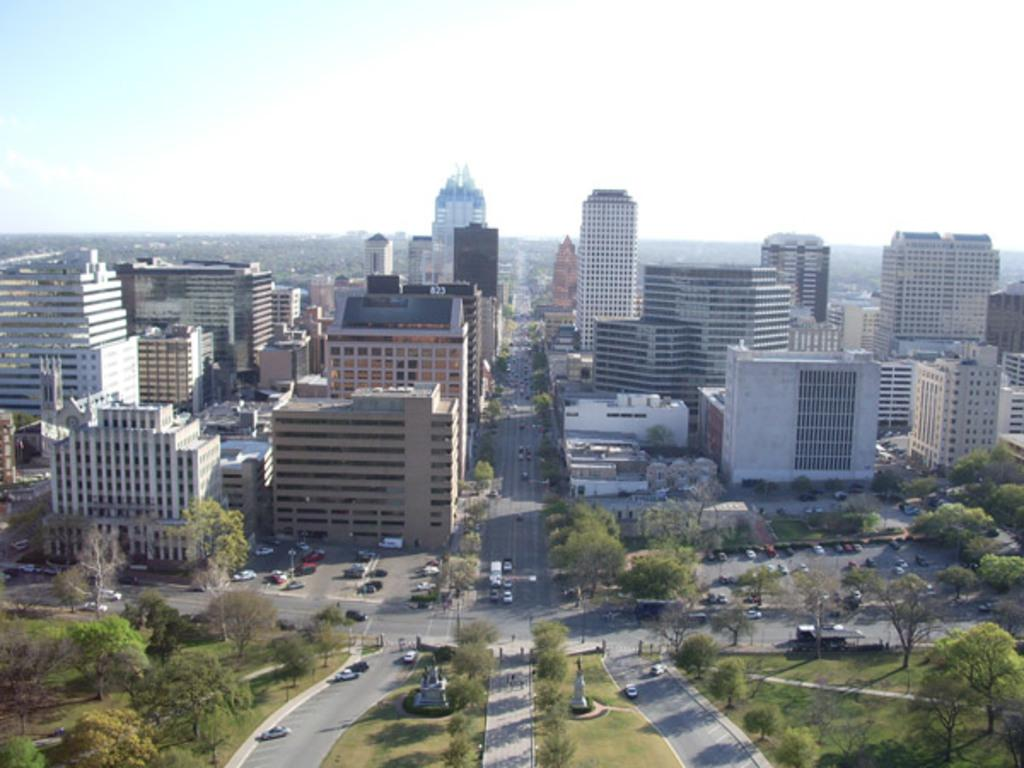What can be seen on the road in the image? There are vehicles on the road in the image. What is located on the grassland in the image? There are statues and trees on the grassland in the image. What can be seen in the background of the image? There are buildings and trees visible in the background of the image. What is visible at the top of the image? The sky is visible at the top of the image. Is there a basketball game happening on the grassland in the image? There is no basketball game present in the image; it features statues and trees on the grassland. Can you touch the birthday cake in the image? There is no birthday cake present in the image. 